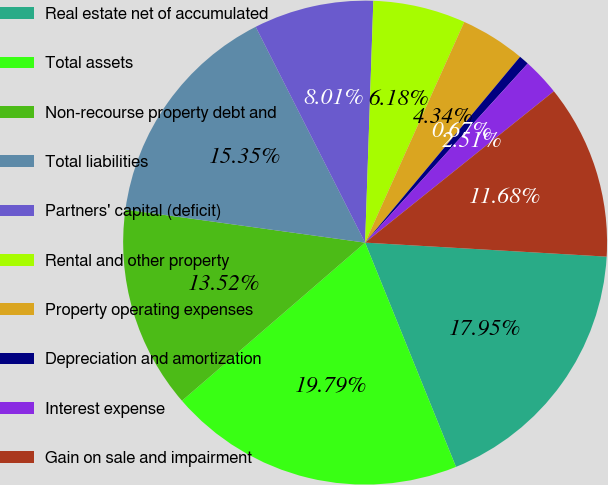Convert chart to OTSL. <chart><loc_0><loc_0><loc_500><loc_500><pie_chart><fcel>Real estate net of accumulated<fcel>Total assets<fcel>Non-recourse property debt and<fcel>Total liabilities<fcel>Partners' capital (deficit)<fcel>Rental and other property<fcel>Property operating expenses<fcel>Depreciation and amortization<fcel>Interest expense<fcel>Gain on sale and impairment<nl><fcel>17.95%<fcel>19.79%<fcel>13.52%<fcel>15.35%<fcel>8.01%<fcel>6.18%<fcel>4.34%<fcel>0.67%<fcel>2.51%<fcel>11.68%<nl></chart> 